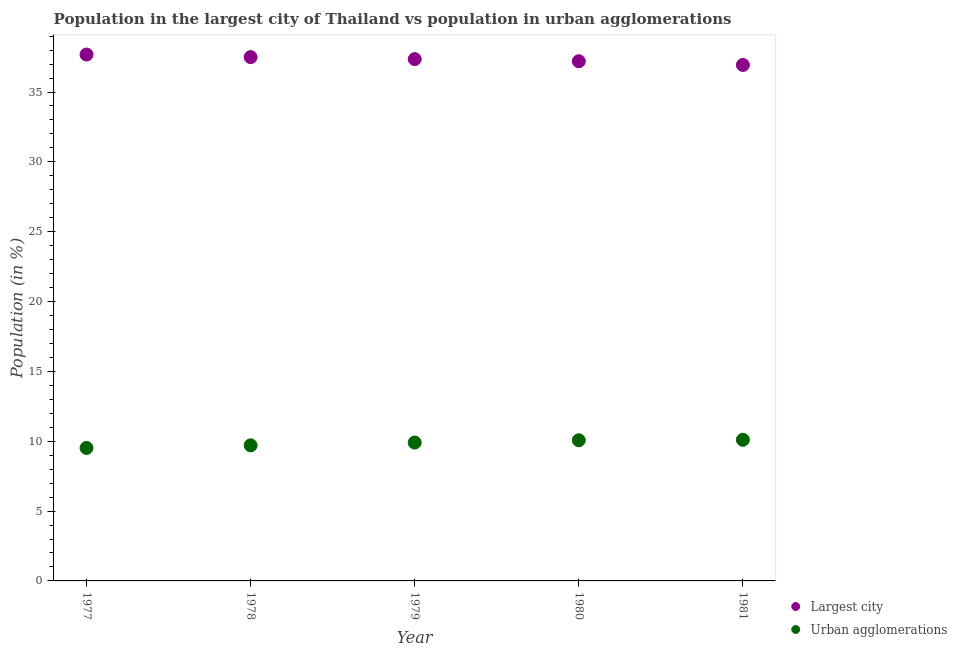How many different coloured dotlines are there?
Give a very brief answer. 2. What is the population in urban agglomerations in 1977?
Offer a terse response. 9.52. Across all years, what is the maximum population in urban agglomerations?
Offer a very short reply. 10.1. Across all years, what is the minimum population in urban agglomerations?
Offer a terse response. 9.52. In which year was the population in urban agglomerations minimum?
Make the answer very short. 1977. What is the total population in urban agglomerations in the graph?
Provide a short and direct response. 49.31. What is the difference between the population in the largest city in 1979 and that in 1980?
Provide a succinct answer. 0.15. What is the difference between the population in the largest city in 1979 and the population in urban agglomerations in 1978?
Offer a terse response. 27.65. What is the average population in urban agglomerations per year?
Your answer should be very brief. 9.86. In the year 1979, what is the difference between the population in urban agglomerations and population in the largest city?
Your answer should be compact. -27.45. In how many years, is the population in urban agglomerations greater than 3 %?
Your answer should be compact. 5. What is the ratio of the population in the largest city in 1979 to that in 1980?
Give a very brief answer. 1. Is the population in the largest city in 1977 less than that in 1981?
Your answer should be compact. No. What is the difference between the highest and the second highest population in the largest city?
Your answer should be compact. 0.18. What is the difference between the highest and the lowest population in urban agglomerations?
Give a very brief answer. 0.58. Is the population in urban agglomerations strictly less than the population in the largest city over the years?
Keep it short and to the point. Yes. How many dotlines are there?
Give a very brief answer. 2. What is the difference between two consecutive major ticks on the Y-axis?
Make the answer very short. 5. Does the graph contain any zero values?
Give a very brief answer. No. Where does the legend appear in the graph?
Keep it short and to the point. Bottom right. How are the legend labels stacked?
Give a very brief answer. Vertical. What is the title of the graph?
Your answer should be compact. Population in the largest city of Thailand vs population in urban agglomerations. Does "Non-pregnant women" appear as one of the legend labels in the graph?
Offer a terse response. No. What is the label or title of the X-axis?
Your answer should be very brief. Year. What is the Population (in %) of Largest city in 1977?
Provide a succinct answer. 37.68. What is the Population (in %) in Urban agglomerations in 1977?
Offer a terse response. 9.52. What is the Population (in %) in Largest city in 1978?
Ensure brevity in your answer.  37.5. What is the Population (in %) in Urban agglomerations in 1978?
Your response must be concise. 9.71. What is the Population (in %) in Largest city in 1979?
Make the answer very short. 37.36. What is the Population (in %) of Urban agglomerations in 1979?
Offer a terse response. 9.91. What is the Population (in %) of Largest city in 1980?
Ensure brevity in your answer.  37.2. What is the Population (in %) in Urban agglomerations in 1980?
Offer a terse response. 10.07. What is the Population (in %) of Largest city in 1981?
Give a very brief answer. 36.94. What is the Population (in %) of Urban agglomerations in 1981?
Provide a short and direct response. 10.1. Across all years, what is the maximum Population (in %) of Largest city?
Keep it short and to the point. 37.68. Across all years, what is the maximum Population (in %) of Urban agglomerations?
Provide a short and direct response. 10.1. Across all years, what is the minimum Population (in %) of Largest city?
Provide a succinct answer. 36.94. Across all years, what is the minimum Population (in %) in Urban agglomerations?
Offer a very short reply. 9.52. What is the total Population (in %) in Largest city in the graph?
Give a very brief answer. 186.68. What is the total Population (in %) of Urban agglomerations in the graph?
Give a very brief answer. 49.31. What is the difference between the Population (in %) of Largest city in 1977 and that in 1978?
Ensure brevity in your answer.  0.18. What is the difference between the Population (in %) of Urban agglomerations in 1977 and that in 1978?
Make the answer very short. -0.19. What is the difference between the Population (in %) in Largest city in 1977 and that in 1979?
Offer a very short reply. 0.33. What is the difference between the Population (in %) of Urban agglomerations in 1977 and that in 1979?
Provide a short and direct response. -0.39. What is the difference between the Population (in %) in Largest city in 1977 and that in 1980?
Ensure brevity in your answer.  0.48. What is the difference between the Population (in %) of Urban agglomerations in 1977 and that in 1980?
Keep it short and to the point. -0.55. What is the difference between the Population (in %) in Largest city in 1977 and that in 1981?
Provide a succinct answer. 0.75. What is the difference between the Population (in %) in Urban agglomerations in 1977 and that in 1981?
Give a very brief answer. -0.58. What is the difference between the Population (in %) in Largest city in 1978 and that in 1979?
Provide a succinct answer. 0.14. What is the difference between the Population (in %) in Urban agglomerations in 1978 and that in 1979?
Offer a terse response. -0.2. What is the difference between the Population (in %) in Largest city in 1978 and that in 1980?
Your answer should be compact. 0.29. What is the difference between the Population (in %) in Urban agglomerations in 1978 and that in 1980?
Provide a succinct answer. -0.36. What is the difference between the Population (in %) in Largest city in 1978 and that in 1981?
Offer a very short reply. 0.56. What is the difference between the Population (in %) in Urban agglomerations in 1978 and that in 1981?
Your answer should be compact. -0.4. What is the difference between the Population (in %) in Largest city in 1979 and that in 1980?
Keep it short and to the point. 0.15. What is the difference between the Population (in %) in Urban agglomerations in 1979 and that in 1980?
Make the answer very short. -0.16. What is the difference between the Population (in %) in Largest city in 1979 and that in 1981?
Keep it short and to the point. 0.42. What is the difference between the Population (in %) in Urban agglomerations in 1979 and that in 1981?
Keep it short and to the point. -0.2. What is the difference between the Population (in %) in Largest city in 1980 and that in 1981?
Your answer should be compact. 0.27. What is the difference between the Population (in %) of Urban agglomerations in 1980 and that in 1981?
Provide a succinct answer. -0.03. What is the difference between the Population (in %) in Largest city in 1977 and the Population (in %) in Urban agglomerations in 1978?
Provide a short and direct response. 27.98. What is the difference between the Population (in %) of Largest city in 1977 and the Population (in %) of Urban agglomerations in 1979?
Give a very brief answer. 27.78. What is the difference between the Population (in %) in Largest city in 1977 and the Population (in %) in Urban agglomerations in 1980?
Ensure brevity in your answer.  27.61. What is the difference between the Population (in %) of Largest city in 1977 and the Population (in %) of Urban agglomerations in 1981?
Your answer should be compact. 27.58. What is the difference between the Population (in %) in Largest city in 1978 and the Population (in %) in Urban agglomerations in 1979?
Provide a short and direct response. 27.59. What is the difference between the Population (in %) of Largest city in 1978 and the Population (in %) of Urban agglomerations in 1980?
Ensure brevity in your answer.  27.43. What is the difference between the Population (in %) in Largest city in 1978 and the Population (in %) in Urban agglomerations in 1981?
Provide a short and direct response. 27.4. What is the difference between the Population (in %) of Largest city in 1979 and the Population (in %) of Urban agglomerations in 1980?
Provide a succinct answer. 27.29. What is the difference between the Population (in %) of Largest city in 1979 and the Population (in %) of Urban agglomerations in 1981?
Your answer should be compact. 27.25. What is the difference between the Population (in %) in Largest city in 1980 and the Population (in %) in Urban agglomerations in 1981?
Give a very brief answer. 27.1. What is the average Population (in %) of Largest city per year?
Ensure brevity in your answer.  37.34. What is the average Population (in %) in Urban agglomerations per year?
Provide a short and direct response. 9.86. In the year 1977, what is the difference between the Population (in %) of Largest city and Population (in %) of Urban agglomerations?
Ensure brevity in your answer.  28.16. In the year 1978, what is the difference between the Population (in %) of Largest city and Population (in %) of Urban agglomerations?
Make the answer very short. 27.79. In the year 1979, what is the difference between the Population (in %) of Largest city and Population (in %) of Urban agglomerations?
Give a very brief answer. 27.45. In the year 1980, what is the difference between the Population (in %) in Largest city and Population (in %) in Urban agglomerations?
Your answer should be very brief. 27.13. In the year 1981, what is the difference between the Population (in %) of Largest city and Population (in %) of Urban agglomerations?
Your answer should be compact. 26.83. What is the ratio of the Population (in %) in Urban agglomerations in 1977 to that in 1978?
Offer a terse response. 0.98. What is the ratio of the Population (in %) of Largest city in 1977 to that in 1979?
Provide a succinct answer. 1.01. What is the ratio of the Population (in %) in Largest city in 1977 to that in 1980?
Ensure brevity in your answer.  1.01. What is the ratio of the Population (in %) of Urban agglomerations in 1977 to that in 1980?
Provide a succinct answer. 0.95. What is the ratio of the Population (in %) in Largest city in 1977 to that in 1981?
Keep it short and to the point. 1.02. What is the ratio of the Population (in %) in Urban agglomerations in 1977 to that in 1981?
Offer a terse response. 0.94. What is the ratio of the Population (in %) in Urban agglomerations in 1978 to that in 1979?
Offer a terse response. 0.98. What is the ratio of the Population (in %) of Largest city in 1978 to that in 1980?
Your answer should be very brief. 1.01. What is the ratio of the Population (in %) of Urban agglomerations in 1978 to that in 1980?
Make the answer very short. 0.96. What is the ratio of the Population (in %) of Largest city in 1978 to that in 1981?
Keep it short and to the point. 1.02. What is the ratio of the Population (in %) in Urban agglomerations in 1978 to that in 1981?
Ensure brevity in your answer.  0.96. What is the ratio of the Population (in %) of Largest city in 1979 to that in 1980?
Ensure brevity in your answer.  1. What is the ratio of the Population (in %) in Urban agglomerations in 1979 to that in 1980?
Your answer should be very brief. 0.98. What is the ratio of the Population (in %) in Largest city in 1979 to that in 1981?
Offer a terse response. 1.01. What is the ratio of the Population (in %) of Urban agglomerations in 1979 to that in 1981?
Your response must be concise. 0.98. What is the ratio of the Population (in %) in Largest city in 1980 to that in 1981?
Your answer should be very brief. 1.01. What is the difference between the highest and the second highest Population (in %) in Largest city?
Your response must be concise. 0.18. What is the difference between the highest and the second highest Population (in %) in Urban agglomerations?
Make the answer very short. 0.03. What is the difference between the highest and the lowest Population (in %) in Largest city?
Keep it short and to the point. 0.75. What is the difference between the highest and the lowest Population (in %) of Urban agglomerations?
Make the answer very short. 0.58. 